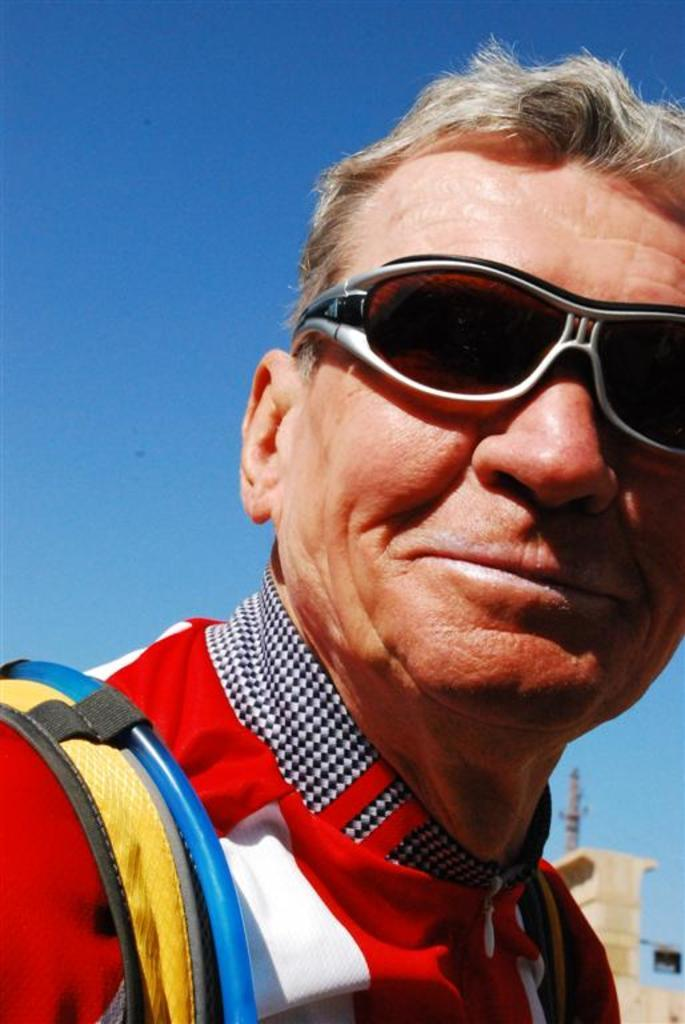What is the main subject of the image? The main subject of the image is a man. What is the man wearing on his eyes? The man is wearing goggles on his eyes. What is the man carrying on his shoulders? The man is carrying a bag on his shoulders. What can be seen in the background of the image? There is a pole, a wall, and the sky visible in the background of the image. How many pizzas is the man holding in the image? There are no pizzas present in the image. What type of book is the laborer reading in the image? There is no laborer or book present in the image. 